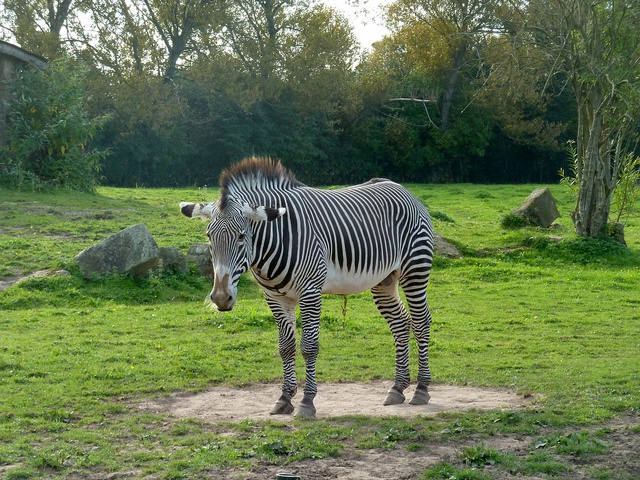Describe the objects in this image and their specific colors. I can see a zebra in lightgray, black, gray, darkgray, and olive tones in this image. 